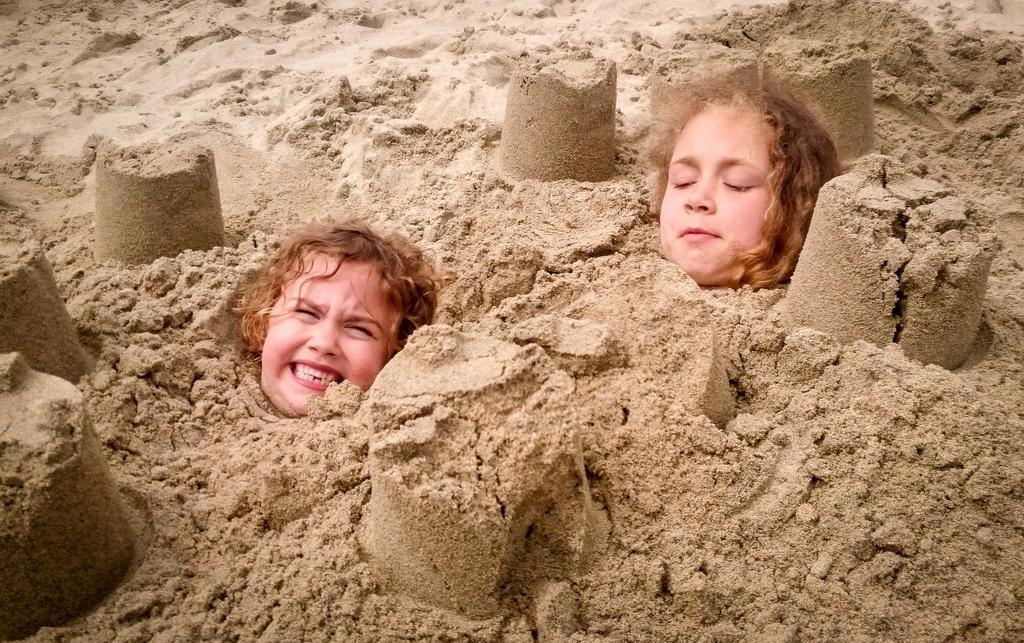How many people are in the image? There are two persons in the image. What is the position or state of the two persons in the image? The two persons are submerged in the sand. What type of muscle can be seen flexing in the image? There is no muscle visible in the image; it features two persons submerged in the sand. What type of fowl is present in the image? There is no fowl present in the image. What type of cheese is being used by the persons in the image? There is no cheese present in the image. 